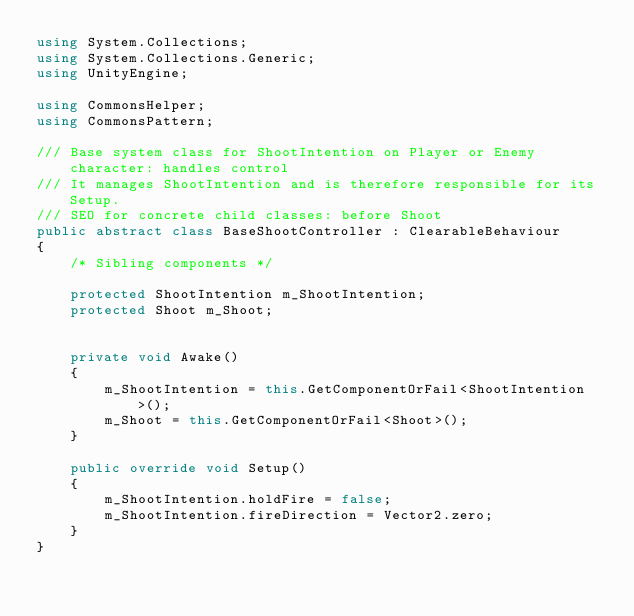<code> <loc_0><loc_0><loc_500><loc_500><_C#_>using System.Collections;
using System.Collections.Generic;
using UnityEngine;

using CommonsHelper;
using CommonsPattern;

/// Base system class for ShootIntention on Player or Enemy character: handles control
/// It manages ShootIntention and is therefore responsible for its Setup.
/// SEO for concrete child classes: before Shoot
public abstract class BaseShootController : ClearableBehaviour
{
    /* Sibling components */
    
    protected ShootIntention m_ShootIntention;
    protected Shoot m_Shoot;
    
    
    private void Awake()
    {
        m_ShootIntention = this.GetComponentOrFail<ShootIntention>();
        m_Shoot = this.GetComponentOrFail<Shoot>();
    }
    
    public override void Setup()
    {
        m_ShootIntention.holdFire = false;
        m_ShootIntention.fireDirection = Vector2.zero;
    }
}
</code> 